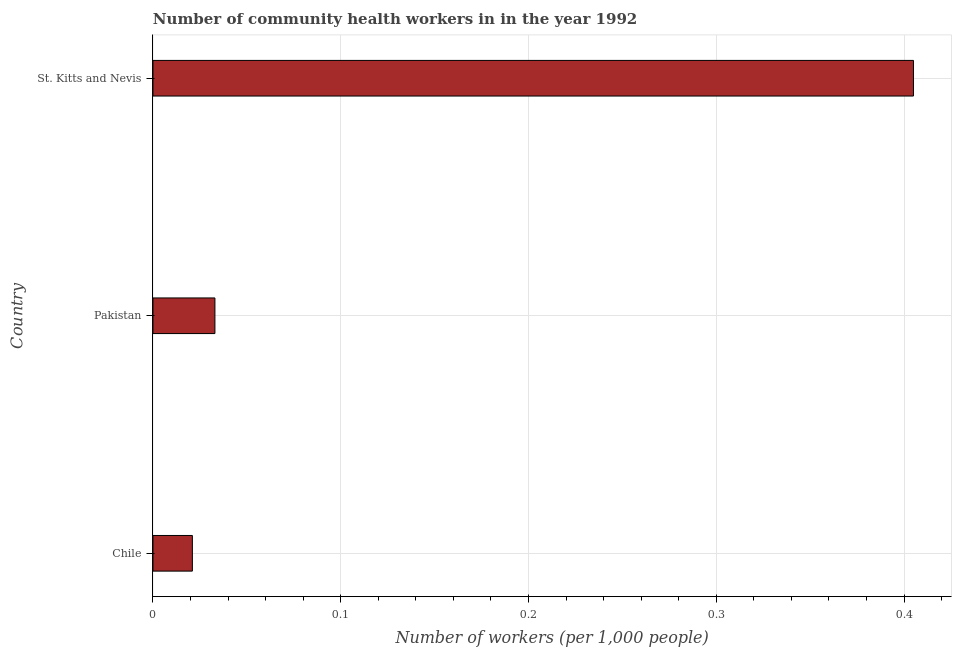Does the graph contain any zero values?
Keep it short and to the point. No. Does the graph contain grids?
Your answer should be compact. Yes. What is the title of the graph?
Provide a succinct answer. Number of community health workers in in the year 1992. What is the label or title of the X-axis?
Your answer should be compact. Number of workers (per 1,0 people). What is the number of community health workers in Pakistan?
Provide a short and direct response. 0.03. Across all countries, what is the maximum number of community health workers?
Provide a succinct answer. 0.41. Across all countries, what is the minimum number of community health workers?
Your answer should be compact. 0.02. In which country was the number of community health workers maximum?
Ensure brevity in your answer.  St. Kitts and Nevis. In which country was the number of community health workers minimum?
Offer a very short reply. Chile. What is the sum of the number of community health workers?
Offer a very short reply. 0.46. What is the difference between the number of community health workers in Chile and St. Kitts and Nevis?
Your answer should be compact. -0.38. What is the average number of community health workers per country?
Keep it short and to the point. 0.15. What is the median number of community health workers?
Offer a very short reply. 0.03. In how many countries, is the number of community health workers greater than 0.32 ?
Your response must be concise. 1. What is the ratio of the number of community health workers in Chile to that in Pakistan?
Offer a terse response. 0.64. Is the number of community health workers in Chile less than that in Pakistan?
Offer a terse response. Yes. Is the difference between the number of community health workers in Pakistan and St. Kitts and Nevis greater than the difference between any two countries?
Offer a terse response. No. What is the difference between the highest and the second highest number of community health workers?
Your answer should be compact. 0.37. Is the sum of the number of community health workers in Chile and St. Kitts and Nevis greater than the maximum number of community health workers across all countries?
Offer a very short reply. Yes. What is the difference between the highest and the lowest number of community health workers?
Give a very brief answer. 0.38. In how many countries, is the number of community health workers greater than the average number of community health workers taken over all countries?
Your answer should be very brief. 1. How many bars are there?
Provide a succinct answer. 3. Are all the bars in the graph horizontal?
Provide a short and direct response. Yes. Are the values on the major ticks of X-axis written in scientific E-notation?
Ensure brevity in your answer.  No. What is the Number of workers (per 1,000 people) of Chile?
Ensure brevity in your answer.  0.02. What is the Number of workers (per 1,000 people) of Pakistan?
Give a very brief answer. 0.03. What is the Number of workers (per 1,000 people) in St. Kitts and Nevis?
Your answer should be very brief. 0.41. What is the difference between the Number of workers (per 1,000 people) in Chile and Pakistan?
Keep it short and to the point. -0.01. What is the difference between the Number of workers (per 1,000 people) in Chile and St. Kitts and Nevis?
Provide a short and direct response. -0.38. What is the difference between the Number of workers (per 1,000 people) in Pakistan and St. Kitts and Nevis?
Offer a very short reply. -0.37. What is the ratio of the Number of workers (per 1,000 people) in Chile to that in Pakistan?
Give a very brief answer. 0.64. What is the ratio of the Number of workers (per 1,000 people) in Chile to that in St. Kitts and Nevis?
Your response must be concise. 0.05. What is the ratio of the Number of workers (per 1,000 people) in Pakistan to that in St. Kitts and Nevis?
Your answer should be very brief. 0.08. 